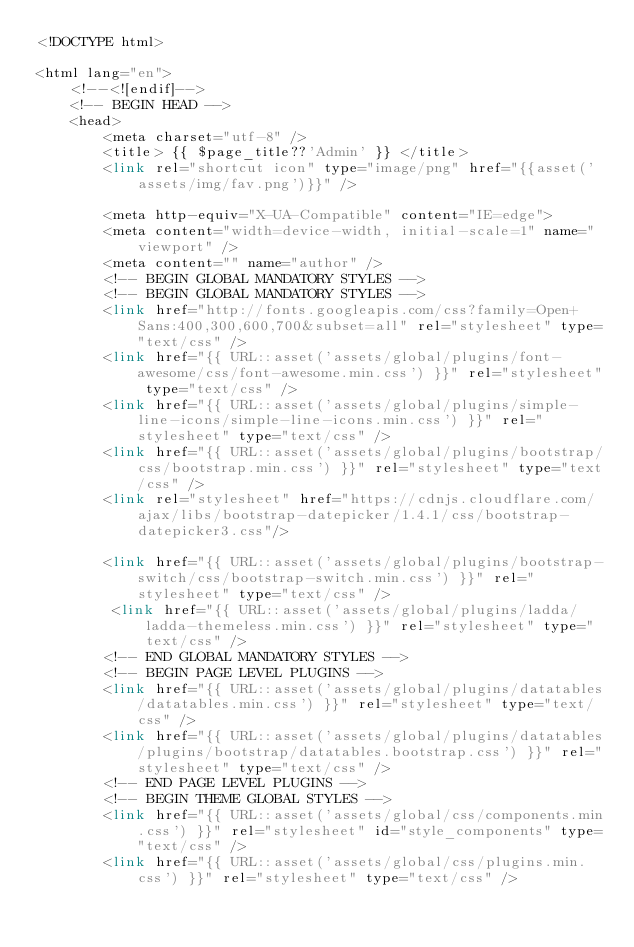<code> <loc_0><loc_0><loc_500><loc_500><_PHP_><!DOCTYPE html>

<html lang="en">
    <!--<![endif]-->
    <!-- BEGIN HEAD -->
    <head>
        <meta charset="utf-8" />
        <title> {{ $page_title??'Admin' }} </title>
        <link rel="shortcut icon" type="image/png" href="{{asset('assets/img/fav.png')}}" />

        <meta http-equiv="X-UA-Compatible" content="IE=edge">
        <meta content="width=device-width, initial-scale=1" name="viewport" />
        <meta content="" name="author" />
        <!-- BEGIN GLOBAL MANDATORY STYLES -->
        <!-- BEGIN GLOBAL MANDATORY STYLES -->
        <link href="http://fonts.googleapis.com/css?family=Open+Sans:400,300,600,700&subset=all" rel="stylesheet" type="text/css" />
        <link href="{{ URL::asset('assets/global/plugins/font-awesome/css/font-awesome.min.css') }}" rel="stylesheet" type="text/css" />
        <link href="{{ URL::asset('assets/global/plugins/simple-line-icons/simple-line-icons.min.css') }}" rel="stylesheet" type="text/css" />
        <link href="{{ URL::asset('assets/global/plugins/bootstrap/css/bootstrap.min.css') }}" rel="stylesheet" type="text/css" />
        <link rel="stylesheet" href="https://cdnjs.cloudflare.com/ajax/libs/bootstrap-datepicker/1.4.1/css/bootstrap-datepicker3.css"/>

        <link href="{{ URL::asset('assets/global/plugins/bootstrap-switch/css/bootstrap-switch.min.css') }}" rel="stylesheet" type="text/css" />
         <link href="{{ URL::asset('assets/global/plugins/ladda/ladda-themeless.min.css') }}" rel="stylesheet" type="text/css" />
        <!-- END GLOBAL MANDATORY STYLES -->
        <!-- BEGIN PAGE LEVEL PLUGINS -->
        <link href="{{ URL::asset('assets/global/plugins/datatables/datatables.min.css') }}" rel="stylesheet" type="text/css" />
        <link href="{{ URL::asset('assets/global/plugins/datatables/plugins/bootstrap/datatables.bootstrap.css') }}" rel="stylesheet" type="text/css" />
        <!-- END PAGE LEVEL PLUGINS -->
        <!-- BEGIN THEME GLOBAL STYLES -->
        <link href="{{ URL::asset('assets/global/css/components.min.css') }}" rel="stylesheet" id="style_components" type="text/css" />
        <link href="{{ URL::asset('assets/global/css/plugins.min.css') }}" rel="stylesheet" type="text/css" /></code> 